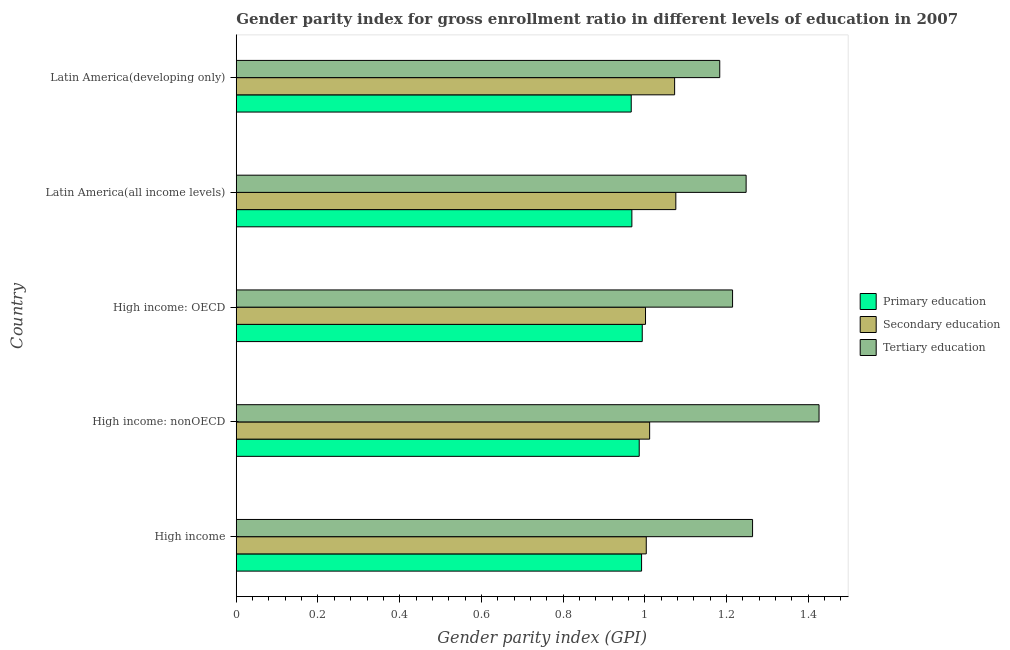How many groups of bars are there?
Ensure brevity in your answer.  5. Are the number of bars per tick equal to the number of legend labels?
Ensure brevity in your answer.  Yes. Are the number of bars on each tick of the Y-axis equal?
Give a very brief answer. Yes. What is the label of the 1st group of bars from the top?
Your answer should be compact. Latin America(developing only). What is the gender parity index in primary education in Latin America(all income levels)?
Offer a very short reply. 0.97. Across all countries, what is the maximum gender parity index in tertiary education?
Your answer should be compact. 1.43. Across all countries, what is the minimum gender parity index in primary education?
Provide a short and direct response. 0.97. In which country was the gender parity index in tertiary education maximum?
Keep it short and to the point. High income: nonOECD. In which country was the gender parity index in tertiary education minimum?
Ensure brevity in your answer.  Latin America(developing only). What is the total gender parity index in secondary education in the graph?
Ensure brevity in your answer.  5.17. What is the difference between the gender parity index in primary education in High income: OECD and the gender parity index in secondary education in Latin America(developing only)?
Provide a succinct answer. -0.08. What is the average gender parity index in tertiary education per country?
Offer a terse response. 1.27. What is the difference between the gender parity index in tertiary education and gender parity index in secondary education in High income: nonOECD?
Your response must be concise. 0.41. In how many countries, is the gender parity index in primary education greater than 1.04 ?
Ensure brevity in your answer.  0. What is the ratio of the gender parity index in primary education in High income to that in High income: nonOECD?
Make the answer very short. 1.01. What is the difference between the highest and the second highest gender parity index in primary education?
Ensure brevity in your answer.  0. What is the difference between the highest and the lowest gender parity index in secondary education?
Keep it short and to the point. 0.07. Is the sum of the gender parity index in primary education in High income: OECD and Latin America(all income levels) greater than the maximum gender parity index in secondary education across all countries?
Ensure brevity in your answer.  Yes. What does the 1st bar from the top in High income: nonOECD represents?
Ensure brevity in your answer.  Tertiary education. What does the 2nd bar from the bottom in Latin America(developing only) represents?
Ensure brevity in your answer.  Secondary education. Does the graph contain any zero values?
Your answer should be compact. No. Does the graph contain grids?
Your answer should be very brief. No. How many legend labels are there?
Make the answer very short. 3. What is the title of the graph?
Offer a terse response. Gender parity index for gross enrollment ratio in different levels of education in 2007. What is the label or title of the X-axis?
Your answer should be very brief. Gender parity index (GPI). What is the Gender parity index (GPI) of Primary education in High income?
Offer a very short reply. 0.99. What is the Gender parity index (GPI) in Secondary education in High income?
Give a very brief answer. 1. What is the Gender parity index (GPI) of Tertiary education in High income?
Make the answer very short. 1.26. What is the Gender parity index (GPI) in Primary education in High income: nonOECD?
Give a very brief answer. 0.99. What is the Gender parity index (GPI) of Secondary education in High income: nonOECD?
Offer a very short reply. 1.01. What is the Gender parity index (GPI) in Tertiary education in High income: nonOECD?
Provide a succinct answer. 1.43. What is the Gender parity index (GPI) of Primary education in High income: OECD?
Offer a very short reply. 0.99. What is the Gender parity index (GPI) in Secondary education in High income: OECD?
Your answer should be very brief. 1. What is the Gender parity index (GPI) of Tertiary education in High income: OECD?
Make the answer very short. 1.21. What is the Gender parity index (GPI) in Primary education in Latin America(all income levels)?
Keep it short and to the point. 0.97. What is the Gender parity index (GPI) in Secondary education in Latin America(all income levels)?
Provide a succinct answer. 1.08. What is the Gender parity index (GPI) of Tertiary education in Latin America(all income levels)?
Ensure brevity in your answer.  1.25. What is the Gender parity index (GPI) of Primary education in Latin America(developing only)?
Keep it short and to the point. 0.97. What is the Gender parity index (GPI) in Secondary education in Latin America(developing only)?
Ensure brevity in your answer.  1.07. What is the Gender parity index (GPI) in Tertiary education in Latin America(developing only)?
Your answer should be very brief. 1.18. Across all countries, what is the maximum Gender parity index (GPI) of Primary education?
Make the answer very short. 0.99. Across all countries, what is the maximum Gender parity index (GPI) of Secondary education?
Make the answer very short. 1.08. Across all countries, what is the maximum Gender parity index (GPI) of Tertiary education?
Your response must be concise. 1.43. Across all countries, what is the minimum Gender parity index (GPI) of Primary education?
Your answer should be compact. 0.97. Across all countries, what is the minimum Gender parity index (GPI) of Secondary education?
Provide a succinct answer. 1. Across all countries, what is the minimum Gender parity index (GPI) of Tertiary education?
Provide a short and direct response. 1.18. What is the total Gender parity index (GPI) in Primary education in the graph?
Your response must be concise. 4.91. What is the total Gender parity index (GPI) of Secondary education in the graph?
Offer a very short reply. 5.17. What is the total Gender parity index (GPI) of Tertiary education in the graph?
Offer a terse response. 6.34. What is the difference between the Gender parity index (GPI) in Primary education in High income and that in High income: nonOECD?
Your answer should be very brief. 0.01. What is the difference between the Gender parity index (GPI) of Secondary education in High income and that in High income: nonOECD?
Provide a succinct answer. -0.01. What is the difference between the Gender parity index (GPI) in Tertiary education in High income and that in High income: nonOECD?
Keep it short and to the point. -0.16. What is the difference between the Gender parity index (GPI) in Primary education in High income and that in High income: OECD?
Offer a very short reply. -0. What is the difference between the Gender parity index (GPI) of Secondary education in High income and that in High income: OECD?
Provide a short and direct response. 0. What is the difference between the Gender parity index (GPI) in Tertiary education in High income and that in High income: OECD?
Make the answer very short. 0.05. What is the difference between the Gender parity index (GPI) in Primary education in High income and that in Latin America(all income levels)?
Ensure brevity in your answer.  0.02. What is the difference between the Gender parity index (GPI) in Secondary education in High income and that in Latin America(all income levels)?
Make the answer very short. -0.07. What is the difference between the Gender parity index (GPI) in Tertiary education in High income and that in Latin America(all income levels)?
Your response must be concise. 0.02. What is the difference between the Gender parity index (GPI) in Primary education in High income and that in Latin America(developing only)?
Provide a short and direct response. 0.03. What is the difference between the Gender parity index (GPI) in Secondary education in High income and that in Latin America(developing only)?
Your answer should be very brief. -0.07. What is the difference between the Gender parity index (GPI) in Tertiary education in High income and that in Latin America(developing only)?
Give a very brief answer. 0.08. What is the difference between the Gender parity index (GPI) in Primary education in High income: nonOECD and that in High income: OECD?
Keep it short and to the point. -0.01. What is the difference between the Gender parity index (GPI) in Secondary education in High income: nonOECD and that in High income: OECD?
Ensure brevity in your answer.  0.01. What is the difference between the Gender parity index (GPI) in Tertiary education in High income: nonOECD and that in High income: OECD?
Keep it short and to the point. 0.21. What is the difference between the Gender parity index (GPI) in Primary education in High income: nonOECD and that in Latin America(all income levels)?
Offer a very short reply. 0.02. What is the difference between the Gender parity index (GPI) in Secondary education in High income: nonOECD and that in Latin America(all income levels)?
Keep it short and to the point. -0.06. What is the difference between the Gender parity index (GPI) of Tertiary education in High income: nonOECD and that in Latin America(all income levels)?
Keep it short and to the point. 0.18. What is the difference between the Gender parity index (GPI) of Primary education in High income: nonOECD and that in Latin America(developing only)?
Keep it short and to the point. 0.02. What is the difference between the Gender parity index (GPI) in Secondary education in High income: nonOECD and that in Latin America(developing only)?
Offer a very short reply. -0.06. What is the difference between the Gender parity index (GPI) in Tertiary education in High income: nonOECD and that in Latin America(developing only)?
Your response must be concise. 0.24. What is the difference between the Gender parity index (GPI) in Primary education in High income: OECD and that in Latin America(all income levels)?
Offer a terse response. 0.03. What is the difference between the Gender parity index (GPI) in Secondary education in High income: OECD and that in Latin America(all income levels)?
Keep it short and to the point. -0.07. What is the difference between the Gender parity index (GPI) in Tertiary education in High income: OECD and that in Latin America(all income levels)?
Offer a terse response. -0.03. What is the difference between the Gender parity index (GPI) in Primary education in High income: OECD and that in Latin America(developing only)?
Ensure brevity in your answer.  0.03. What is the difference between the Gender parity index (GPI) in Secondary education in High income: OECD and that in Latin America(developing only)?
Offer a terse response. -0.07. What is the difference between the Gender parity index (GPI) of Tertiary education in High income: OECD and that in Latin America(developing only)?
Give a very brief answer. 0.03. What is the difference between the Gender parity index (GPI) in Primary education in Latin America(all income levels) and that in Latin America(developing only)?
Provide a succinct answer. 0. What is the difference between the Gender parity index (GPI) in Secondary education in Latin America(all income levels) and that in Latin America(developing only)?
Your answer should be very brief. 0. What is the difference between the Gender parity index (GPI) in Tertiary education in Latin America(all income levels) and that in Latin America(developing only)?
Keep it short and to the point. 0.06. What is the difference between the Gender parity index (GPI) in Primary education in High income and the Gender parity index (GPI) in Secondary education in High income: nonOECD?
Make the answer very short. -0.02. What is the difference between the Gender parity index (GPI) of Primary education in High income and the Gender parity index (GPI) of Tertiary education in High income: nonOECD?
Your response must be concise. -0.43. What is the difference between the Gender parity index (GPI) in Secondary education in High income and the Gender parity index (GPI) in Tertiary education in High income: nonOECD?
Provide a succinct answer. -0.42. What is the difference between the Gender parity index (GPI) of Primary education in High income and the Gender parity index (GPI) of Secondary education in High income: OECD?
Your answer should be very brief. -0.01. What is the difference between the Gender parity index (GPI) in Primary education in High income and the Gender parity index (GPI) in Tertiary education in High income: OECD?
Give a very brief answer. -0.22. What is the difference between the Gender parity index (GPI) of Secondary education in High income and the Gender parity index (GPI) of Tertiary education in High income: OECD?
Your response must be concise. -0.21. What is the difference between the Gender parity index (GPI) of Primary education in High income and the Gender parity index (GPI) of Secondary education in Latin America(all income levels)?
Your answer should be very brief. -0.08. What is the difference between the Gender parity index (GPI) of Primary education in High income and the Gender parity index (GPI) of Tertiary education in Latin America(all income levels)?
Your response must be concise. -0.26. What is the difference between the Gender parity index (GPI) of Secondary education in High income and the Gender parity index (GPI) of Tertiary education in Latin America(all income levels)?
Ensure brevity in your answer.  -0.24. What is the difference between the Gender parity index (GPI) of Primary education in High income and the Gender parity index (GPI) of Secondary education in Latin America(developing only)?
Keep it short and to the point. -0.08. What is the difference between the Gender parity index (GPI) of Primary education in High income and the Gender parity index (GPI) of Tertiary education in Latin America(developing only)?
Provide a short and direct response. -0.19. What is the difference between the Gender parity index (GPI) in Secondary education in High income and the Gender parity index (GPI) in Tertiary education in Latin America(developing only)?
Make the answer very short. -0.18. What is the difference between the Gender parity index (GPI) of Primary education in High income: nonOECD and the Gender parity index (GPI) of Secondary education in High income: OECD?
Ensure brevity in your answer.  -0.02. What is the difference between the Gender parity index (GPI) in Primary education in High income: nonOECD and the Gender parity index (GPI) in Tertiary education in High income: OECD?
Your answer should be very brief. -0.23. What is the difference between the Gender parity index (GPI) of Secondary education in High income: nonOECD and the Gender parity index (GPI) of Tertiary education in High income: OECD?
Keep it short and to the point. -0.2. What is the difference between the Gender parity index (GPI) of Primary education in High income: nonOECD and the Gender parity index (GPI) of Secondary education in Latin America(all income levels)?
Your answer should be compact. -0.09. What is the difference between the Gender parity index (GPI) of Primary education in High income: nonOECD and the Gender parity index (GPI) of Tertiary education in Latin America(all income levels)?
Your answer should be very brief. -0.26. What is the difference between the Gender parity index (GPI) of Secondary education in High income: nonOECD and the Gender parity index (GPI) of Tertiary education in Latin America(all income levels)?
Make the answer very short. -0.24. What is the difference between the Gender parity index (GPI) of Primary education in High income: nonOECD and the Gender parity index (GPI) of Secondary education in Latin America(developing only)?
Your answer should be compact. -0.09. What is the difference between the Gender parity index (GPI) of Primary education in High income: nonOECD and the Gender parity index (GPI) of Tertiary education in Latin America(developing only)?
Offer a very short reply. -0.2. What is the difference between the Gender parity index (GPI) in Secondary education in High income: nonOECD and the Gender parity index (GPI) in Tertiary education in Latin America(developing only)?
Your answer should be compact. -0.17. What is the difference between the Gender parity index (GPI) of Primary education in High income: OECD and the Gender parity index (GPI) of Secondary education in Latin America(all income levels)?
Provide a short and direct response. -0.08. What is the difference between the Gender parity index (GPI) of Primary education in High income: OECD and the Gender parity index (GPI) of Tertiary education in Latin America(all income levels)?
Your answer should be compact. -0.25. What is the difference between the Gender parity index (GPI) of Secondary education in High income: OECD and the Gender parity index (GPI) of Tertiary education in Latin America(all income levels)?
Provide a succinct answer. -0.25. What is the difference between the Gender parity index (GPI) in Primary education in High income: OECD and the Gender parity index (GPI) in Secondary education in Latin America(developing only)?
Your response must be concise. -0.08. What is the difference between the Gender parity index (GPI) of Primary education in High income: OECD and the Gender parity index (GPI) of Tertiary education in Latin America(developing only)?
Provide a short and direct response. -0.19. What is the difference between the Gender parity index (GPI) of Secondary education in High income: OECD and the Gender parity index (GPI) of Tertiary education in Latin America(developing only)?
Your answer should be very brief. -0.18. What is the difference between the Gender parity index (GPI) in Primary education in Latin America(all income levels) and the Gender parity index (GPI) in Secondary education in Latin America(developing only)?
Your answer should be very brief. -0.1. What is the difference between the Gender parity index (GPI) in Primary education in Latin America(all income levels) and the Gender parity index (GPI) in Tertiary education in Latin America(developing only)?
Offer a terse response. -0.22. What is the difference between the Gender parity index (GPI) of Secondary education in Latin America(all income levels) and the Gender parity index (GPI) of Tertiary education in Latin America(developing only)?
Keep it short and to the point. -0.11. What is the average Gender parity index (GPI) of Primary education per country?
Give a very brief answer. 0.98. What is the average Gender parity index (GPI) in Secondary education per country?
Offer a terse response. 1.03. What is the average Gender parity index (GPI) of Tertiary education per country?
Provide a succinct answer. 1.27. What is the difference between the Gender parity index (GPI) of Primary education and Gender parity index (GPI) of Secondary education in High income?
Ensure brevity in your answer.  -0.01. What is the difference between the Gender parity index (GPI) of Primary education and Gender parity index (GPI) of Tertiary education in High income?
Your answer should be very brief. -0.27. What is the difference between the Gender parity index (GPI) of Secondary education and Gender parity index (GPI) of Tertiary education in High income?
Give a very brief answer. -0.26. What is the difference between the Gender parity index (GPI) in Primary education and Gender parity index (GPI) in Secondary education in High income: nonOECD?
Your answer should be compact. -0.03. What is the difference between the Gender parity index (GPI) of Primary education and Gender parity index (GPI) of Tertiary education in High income: nonOECD?
Your response must be concise. -0.44. What is the difference between the Gender parity index (GPI) of Secondary education and Gender parity index (GPI) of Tertiary education in High income: nonOECD?
Give a very brief answer. -0.41. What is the difference between the Gender parity index (GPI) in Primary education and Gender parity index (GPI) in Secondary education in High income: OECD?
Your answer should be compact. -0.01. What is the difference between the Gender parity index (GPI) of Primary education and Gender parity index (GPI) of Tertiary education in High income: OECD?
Provide a short and direct response. -0.22. What is the difference between the Gender parity index (GPI) of Secondary education and Gender parity index (GPI) of Tertiary education in High income: OECD?
Give a very brief answer. -0.21. What is the difference between the Gender parity index (GPI) of Primary education and Gender parity index (GPI) of Secondary education in Latin America(all income levels)?
Your answer should be very brief. -0.11. What is the difference between the Gender parity index (GPI) of Primary education and Gender parity index (GPI) of Tertiary education in Latin America(all income levels)?
Offer a terse response. -0.28. What is the difference between the Gender parity index (GPI) of Secondary education and Gender parity index (GPI) of Tertiary education in Latin America(all income levels)?
Offer a terse response. -0.17. What is the difference between the Gender parity index (GPI) in Primary education and Gender parity index (GPI) in Secondary education in Latin America(developing only)?
Give a very brief answer. -0.11. What is the difference between the Gender parity index (GPI) of Primary education and Gender parity index (GPI) of Tertiary education in Latin America(developing only)?
Provide a succinct answer. -0.22. What is the difference between the Gender parity index (GPI) in Secondary education and Gender parity index (GPI) in Tertiary education in Latin America(developing only)?
Give a very brief answer. -0.11. What is the ratio of the Gender parity index (GPI) of Primary education in High income to that in High income: nonOECD?
Your answer should be very brief. 1.01. What is the ratio of the Gender parity index (GPI) of Tertiary education in High income to that in High income: nonOECD?
Ensure brevity in your answer.  0.89. What is the ratio of the Gender parity index (GPI) in Primary education in High income to that in High income: OECD?
Your answer should be compact. 1. What is the ratio of the Gender parity index (GPI) in Secondary education in High income to that in High income: OECD?
Offer a terse response. 1. What is the ratio of the Gender parity index (GPI) in Tertiary education in High income to that in High income: OECD?
Provide a succinct answer. 1.04. What is the ratio of the Gender parity index (GPI) of Primary education in High income to that in Latin America(all income levels)?
Your response must be concise. 1.02. What is the ratio of the Gender parity index (GPI) in Secondary education in High income to that in Latin America(all income levels)?
Give a very brief answer. 0.93. What is the ratio of the Gender parity index (GPI) of Tertiary education in High income to that in Latin America(all income levels)?
Give a very brief answer. 1.01. What is the ratio of the Gender parity index (GPI) in Primary education in High income to that in Latin America(developing only)?
Your answer should be compact. 1.03. What is the ratio of the Gender parity index (GPI) of Secondary education in High income to that in Latin America(developing only)?
Provide a short and direct response. 0.94. What is the ratio of the Gender parity index (GPI) in Tertiary education in High income to that in Latin America(developing only)?
Make the answer very short. 1.07. What is the ratio of the Gender parity index (GPI) in Secondary education in High income: nonOECD to that in High income: OECD?
Your response must be concise. 1.01. What is the ratio of the Gender parity index (GPI) in Tertiary education in High income: nonOECD to that in High income: OECD?
Provide a succinct answer. 1.17. What is the ratio of the Gender parity index (GPI) of Primary education in High income: nonOECD to that in Latin America(all income levels)?
Ensure brevity in your answer.  1.02. What is the ratio of the Gender parity index (GPI) of Secondary education in High income: nonOECD to that in Latin America(all income levels)?
Provide a short and direct response. 0.94. What is the ratio of the Gender parity index (GPI) in Tertiary education in High income: nonOECD to that in Latin America(all income levels)?
Make the answer very short. 1.14. What is the ratio of the Gender parity index (GPI) in Primary education in High income: nonOECD to that in Latin America(developing only)?
Keep it short and to the point. 1.02. What is the ratio of the Gender parity index (GPI) of Secondary education in High income: nonOECD to that in Latin America(developing only)?
Offer a very short reply. 0.94. What is the ratio of the Gender parity index (GPI) of Tertiary education in High income: nonOECD to that in Latin America(developing only)?
Offer a very short reply. 1.21. What is the ratio of the Gender parity index (GPI) of Primary education in High income: OECD to that in Latin America(all income levels)?
Your answer should be very brief. 1.03. What is the ratio of the Gender parity index (GPI) in Secondary education in High income: OECD to that in Latin America(all income levels)?
Give a very brief answer. 0.93. What is the ratio of the Gender parity index (GPI) in Tertiary education in High income: OECD to that in Latin America(all income levels)?
Your response must be concise. 0.97. What is the ratio of the Gender parity index (GPI) in Primary education in High income: OECD to that in Latin America(developing only)?
Your answer should be compact. 1.03. What is the ratio of the Gender parity index (GPI) in Secondary education in High income: OECD to that in Latin America(developing only)?
Make the answer very short. 0.93. What is the ratio of the Gender parity index (GPI) in Tertiary education in High income: OECD to that in Latin America(developing only)?
Your answer should be compact. 1.03. What is the ratio of the Gender parity index (GPI) in Secondary education in Latin America(all income levels) to that in Latin America(developing only)?
Your response must be concise. 1. What is the ratio of the Gender parity index (GPI) in Tertiary education in Latin America(all income levels) to that in Latin America(developing only)?
Your answer should be compact. 1.05. What is the difference between the highest and the second highest Gender parity index (GPI) in Primary education?
Your answer should be very brief. 0. What is the difference between the highest and the second highest Gender parity index (GPI) in Secondary education?
Make the answer very short. 0. What is the difference between the highest and the second highest Gender parity index (GPI) of Tertiary education?
Your response must be concise. 0.16. What is the difference between the highest and the lowest Gender parity index (GPI) in Primary education?
Keep it short and to the point. 0.03. What is the difference between the highest and the lowest Gender parity index (GPI) in Secondary education?
Ensure brevity in your answer.  0.07. What is the difference between the highest and the lowest Gender parity index (GPI) of Tertiary education?
Your answer should be compact. 0.24. 